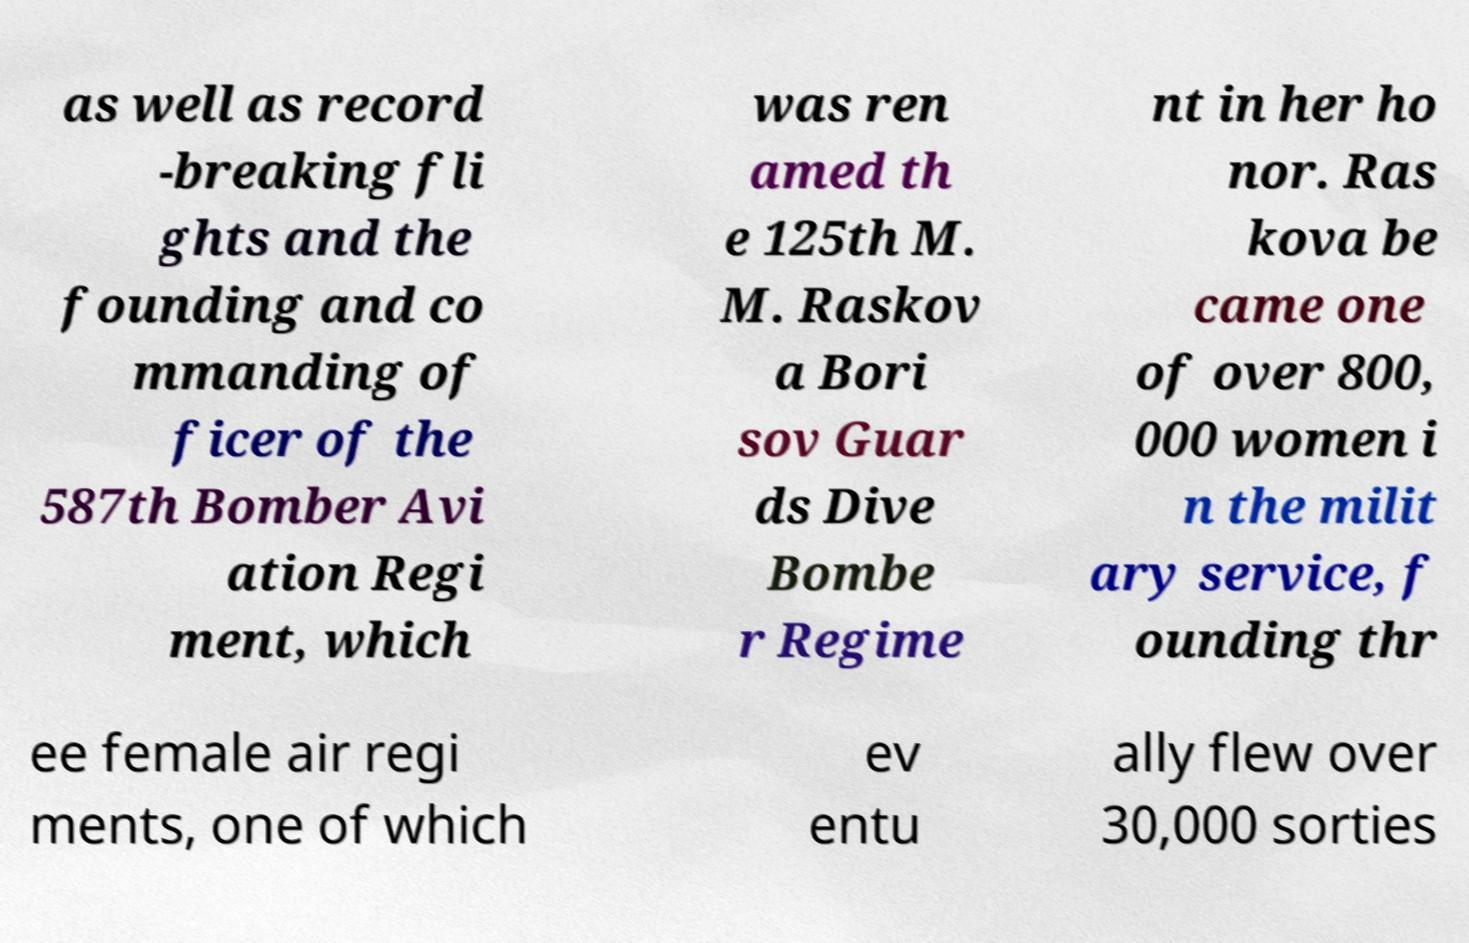Could you assist in decoding the text presented in this image and type it out clearly? as well as record -breaking fli ghts and the founding and co mmanding of ficer of the 587th Bomber Avi ation Regi ment, which was ren amed th e 125th M. M. Raskov a Bori sov Guar ds Dive Bombe r Regime nt in her ho nor. Ras kova be came one of over 800, 000 women i n the milit ary service, f ounding thr ee female air regi ments, one of which ev entu ally flew over 30,000 sorties 